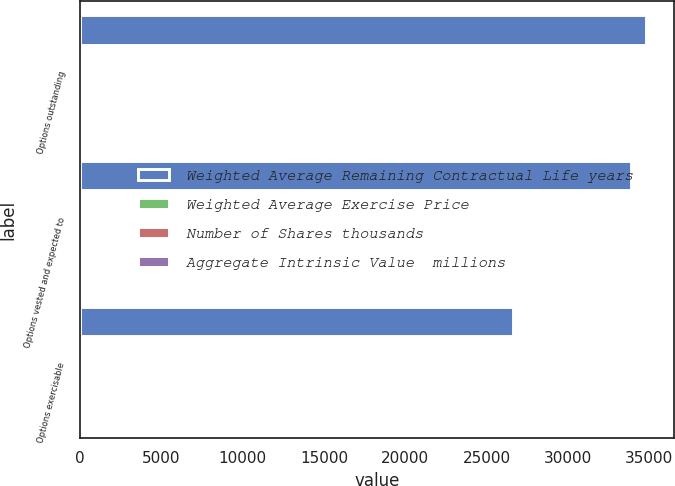Convert chart. <chart><loc_0><loc_0><loc_500><loc_500><stacked_bar_chart><ecel><fcel>Options outstanding<fcel>Options vested and expected to<fcel>Options exercisable<nl><fcel>Weighted Average Remaining Contractual Life years<fcel>34802<fcel>33856<fcel>26622<nl><fcel>Weighted Average Exercise Price<fcel>31.47<fcel>31.52<fcel>32.31<nl><fcel>Number of Shares thousands<fcel>3.24<fcel>3.17<fcel>2.56<nl><fcel>Aggregate Intrinsic Value  millions<fcel>68<fcel>65.6<fcel>42.1<nl></chart> 